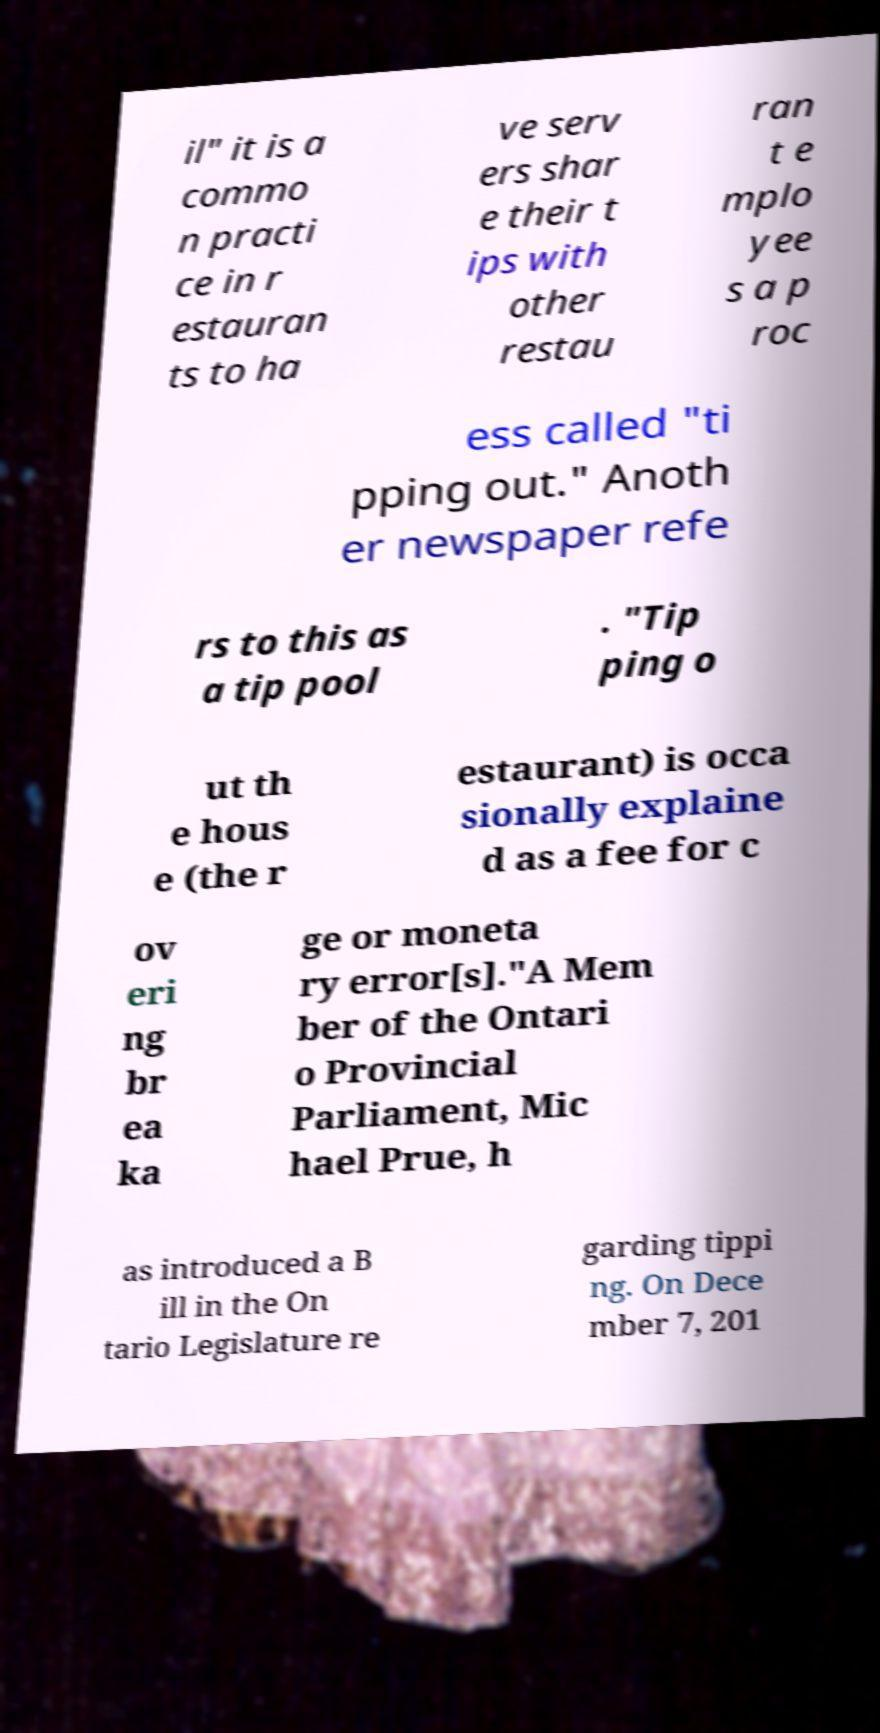Could you assist in decoding the text presented in this image and type it out clearly? il" it is a commo n practi ce in r estauran ts to ha ve serv ers shar e their t ips with other restau ran t e mplo yee s a p roc ess called "ti pping out." Anoth er newspaper refe rs to this as a tip pool . "Tip ping o ut th e hous e (the r estaurant) is occa sionally explaine d as a fee for c ov eri ng br ea ka ge or moneta ry error[s]."A Mem ber of the Ontari o Provincial Parliament, Mic hael Prue, h as introduced a B ill in the On tario Legislature re garding tippi ng. On Dece mber 7, 201 